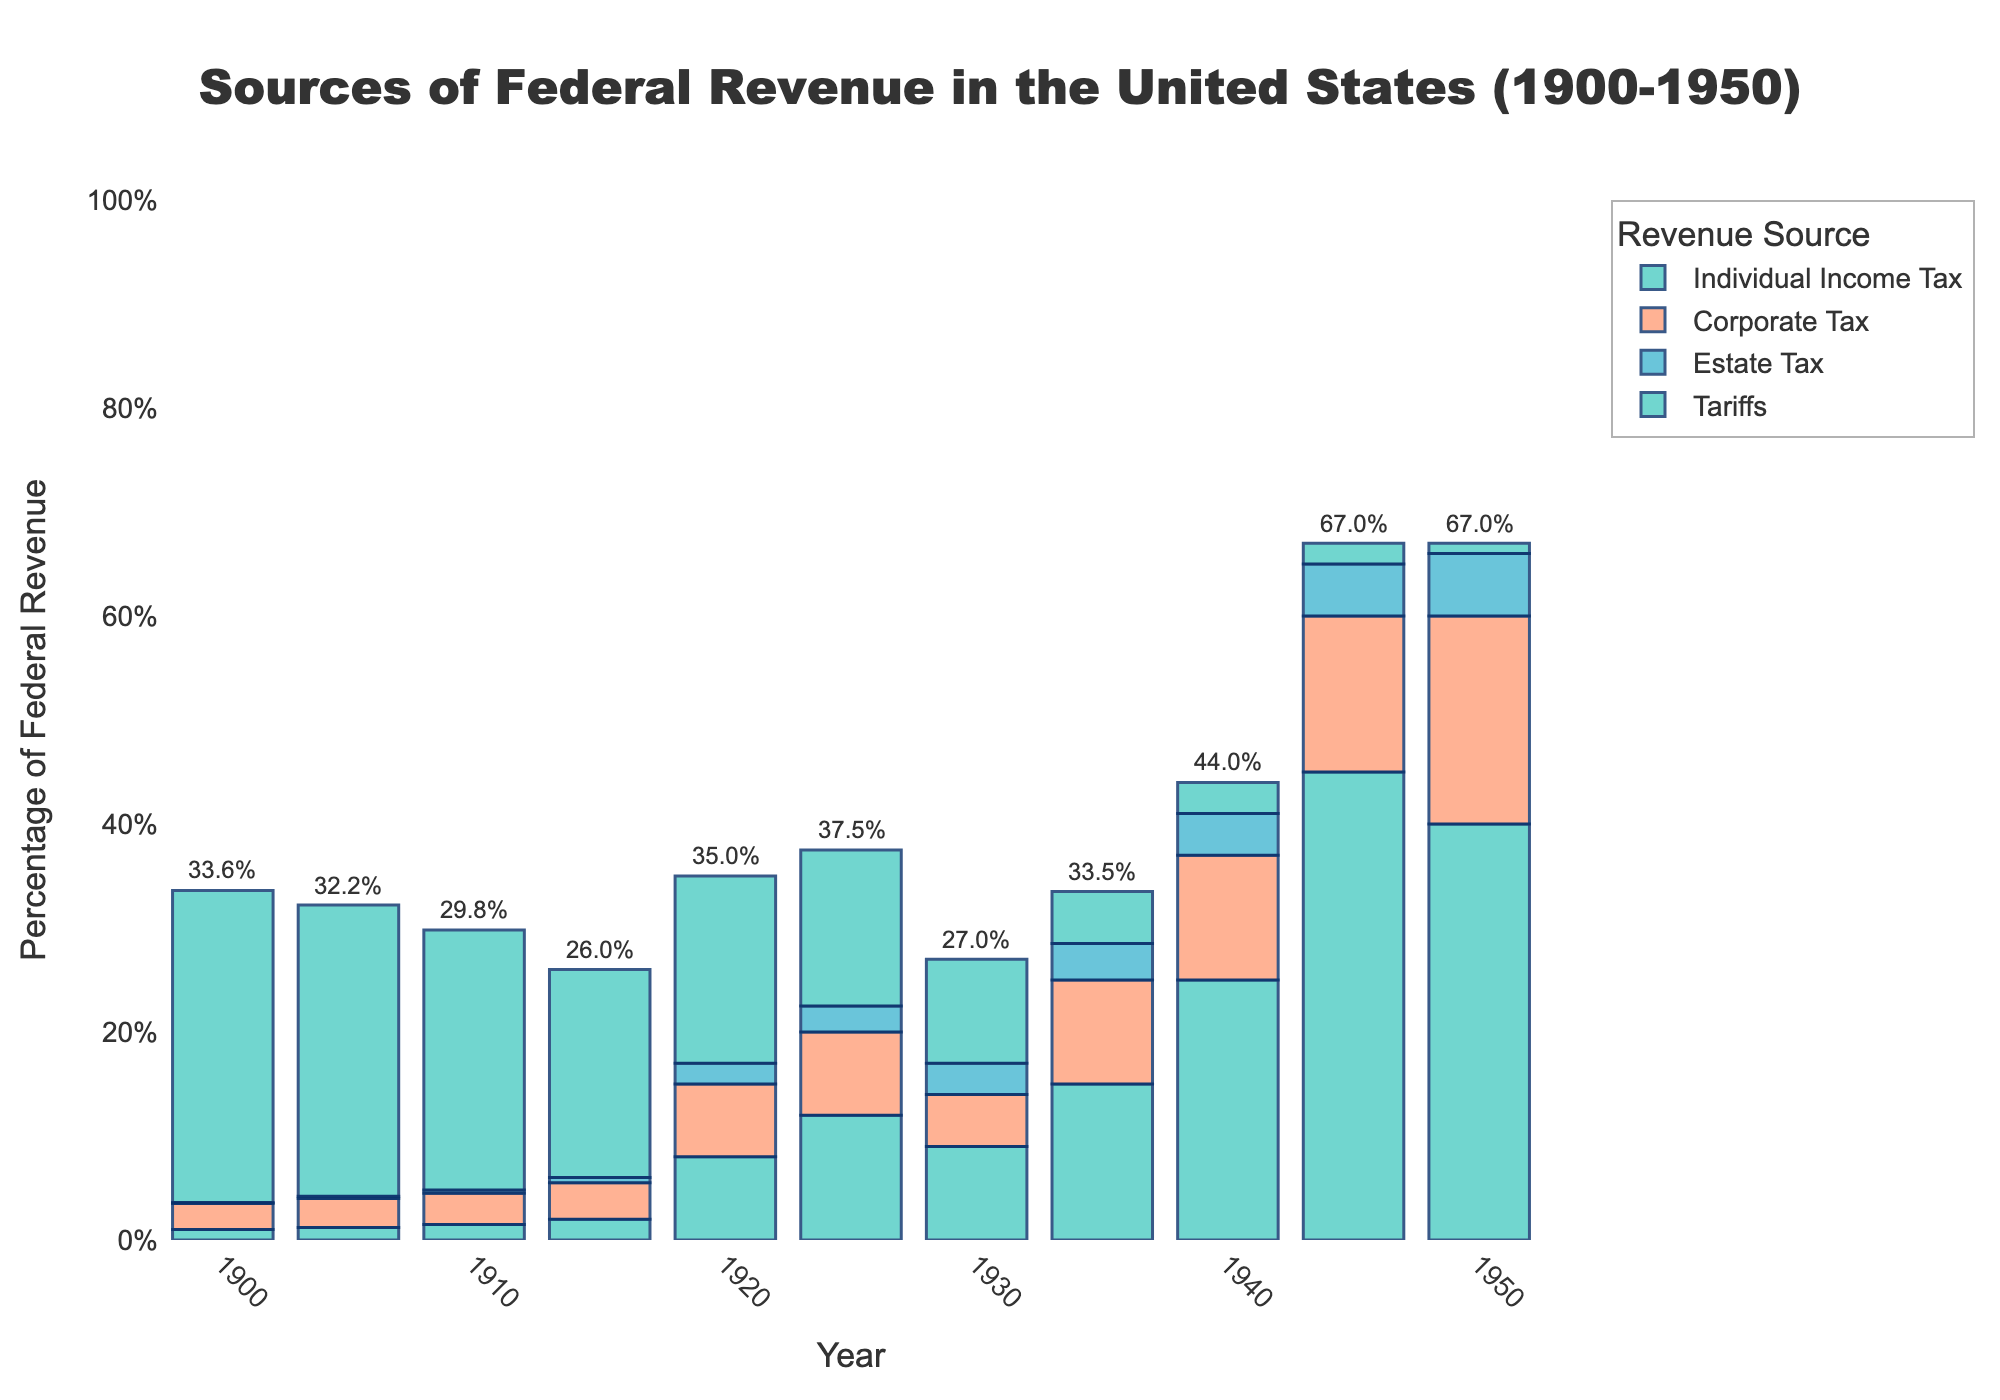What period saw the most significant increase in the individual income tax contribution as a percentage of federal revenue? The individual income tax contribution increased notably from 1940 (25.0%) to 1945 (45.0%), which is a rise of 20%. To find the most significant increase, we can compare the differences between consecutive periods, and the largest difference is between 1940 and 1945.
Answer: 1940 to 1945 Which revenue source had the highest percentage in 1900? In 1900, tariffs were by far the highest percentage of federal revenue at 30.0%, followed by corporate tax at 2.5%, individual income tax at 1.0%, and estate tax at 0.1%.
Answer: Tariffs By how much did the estate tax contribution to federal revenue increase from 1900 to 1950? The estate tax contribution increased from 0.1% in 1900 to 6.0% in 1950, which is an increase of 5.9%.
Answer: 5.9% Which years had the lowest and the highest combined revenue from individual income tax and corporate tax? The lowest combined revenue from individual income tax and corporate tax was in 1900 (1.0% + 2.5% = 3.5%), and the highest was in 1945 (45.0% + 15.0% = 60.0%).
Answer: 1900 and 1945 In what year do tariffs fall below estate tax as a percentage of federal revenue? In 1930, tariffs contributed 10.0% while the estate tax was at 3.0%. However, by 1935, tariffs were only at 5.0% whereas the estate tax was at 3.5%. Thus, tariffs fall below the estate tax by 1935.
Answer: 1935 How did the contribution of corporate tax to federal revenue change from 1920 to 1930? In 1920, the corporate tax contribution was 7.0%, and by 1930, it had decreased to 5.0%, indicating a reduction of 2.0%.
Answer: Decreased by 2.0% What's the average percentage of tariffs as a source of federal revenue across the entire period? Adding the tariffs percentages for each year (30.0 + 28.0 + 25.0 + 20.0 + 18.0 + 15.0 + 10.0 + 5.0 + 3.0 + 2.0 + 1.0 = 157.0) and dividing by the number of data points (11 years), we get an average of approximately 14.3%.
Answer: 14.3% How does the height of the individual income tax bar in 1935 compare to that in 1940? In 1935, the height of the individual income tax bar is lower (15.0%) compared to 1940 where it reaches 25.0%. The difference is 10.0%.
Answer: Lower by 10.0% 